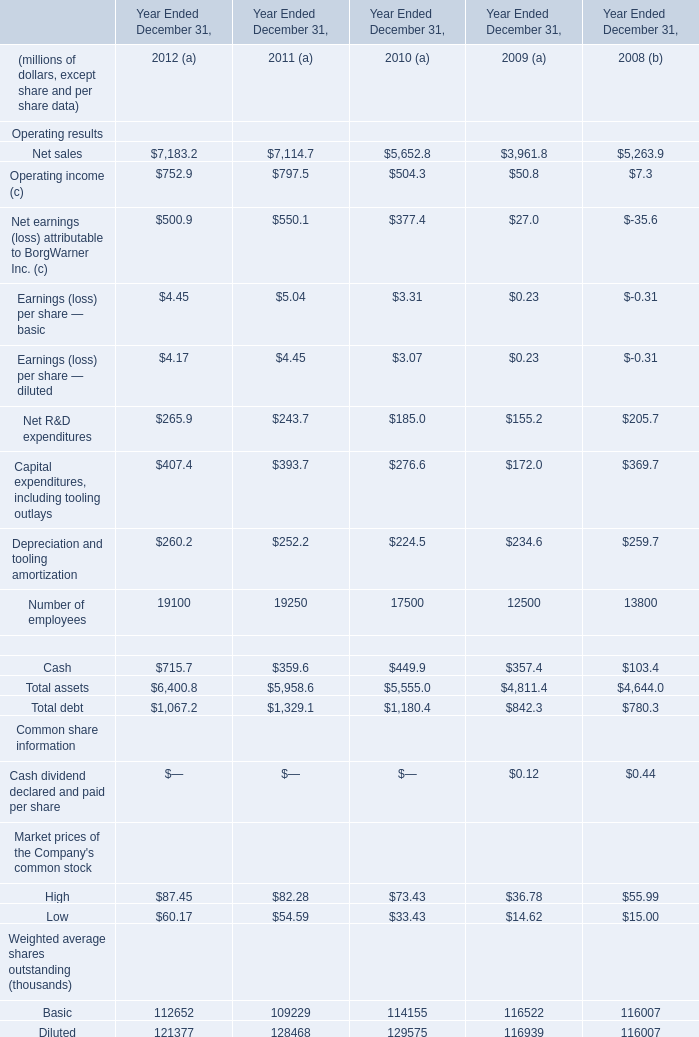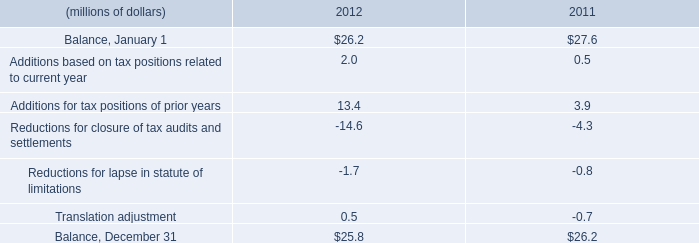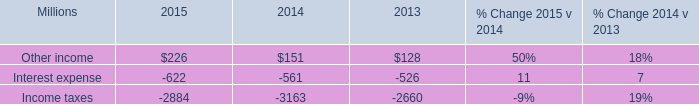What is the average value of Cash in Table 0 and Additions for tax positions of prior years in Table 1 in 2011? (in million) 
Computations: ((359.6 + 3.9) / 2)
Answer: 181.75. 